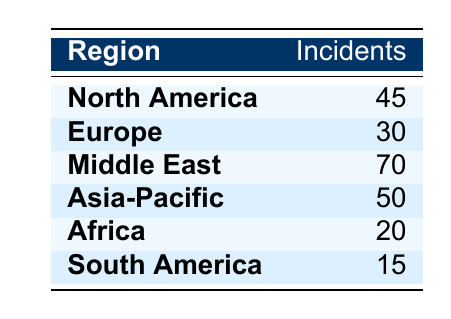What region had the highest number of incidents? By looking through the table, we can see that the Middle East has the highest incidents listed with a total of 70.
Answer: Middle East Which region had fewer than 25 incidents? Scanning through the table, we find that South America (15 incidents) and Africa (20 incidents) both have fewer than 25 incidents.
Answer: South America, Africa What is the sum of incidents for North America and Europe? To find the sum, we take the incidents from North America (45) and Europe (30) and add them together: 45 + 30 = 75.
Answer: 75 Is Africa's incident count greater than South America’s? Africa has 20 incidents while South America has 15, so Africa's count is indeed greater. Therefore, the answer is yes.
Answer: Yes What is the average number of incidents across all regions listed? We first sum all incidents (45 + 30 + 70 + 50 + 20 + 15 = 230) and there are 6 regions, so we then divide the total incidents by the number of regions: 230 / 6 = 38.33.
Answer: 38.33 Which region had more incidents, Asia-Pacific or Africa? Asia-Pacific has 50 incidents while Africa has 20 incidents, thus Asia-Pacific had more incidents.
Answer: Asia-Pacific What is the difference in incidents between the region with the most incidents and the region with the least incidents? The region with the most incidents is the Middle East (70), while the region with the least is South America (15). The difference is calculated as 70 - 15 = 55.
Answer: 55 Is the total number of incidents in Asia-Pacific and Europe combined greater than 80? First, we sum the incidents in Asia-Pacific (50) and Europe (30) which equals 80. Since we are looking for a sum greater than 80, the result is no.
Answer: No 